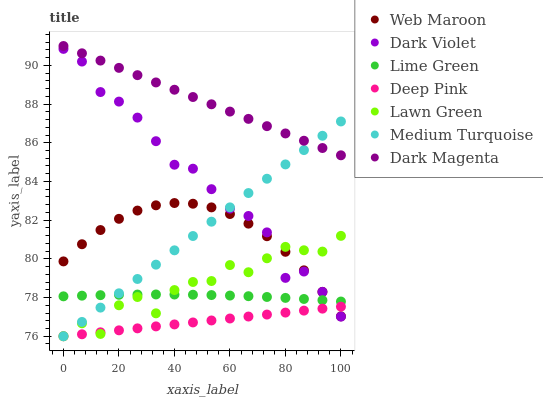Does Deep Pink have the minimum area under the curve?
Answer yes or no. Yes. Does Dark Magenta have the maximum area under the curve?
Answer yes or no. Yes. Does Dark Magenta have the minimum area under the curve?
Answer yes or no. No. Does Deep Pink have the maximum area under the curve?
Answer yes or no. No. Is Medium Turquoise the smoothest?
Answer yes or no. Yes. Is Lawn Green the roughest?
Answer yes or no. Yes. Is Deep Pink the smoothest?
Answer yes or no. No. Is Deep Pink the roughest?
Answer yes or no. No. Does Lawn Green have the lowest value?
Answer yes or no. Yes. Does Dark Magenta have the lowest value?
Answer yes or no. No. Does Dark Magenta have the highest value?
Answer yes or no. Yes. Does Deep Pink have the highest value?
Answer yes or no. No. Is Lawn Green less than Dark Magenta?
Answer yes or no. Yes. Is Lime Green greater than Deep Pink?
Answer yes or no. Yes. Does Deep Pink intersect Dark Violet?
Answer yes or no. Yes. Is Deep Pink less than Dark Violet?
Answer yes or no. No. Is Deep Pink greater than Dark Violet?
Answer yes or no. No. Does Lawn Green intersect Dark Magenta?
Answer yes or no. No. 